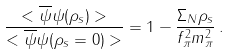Convert formula to latex. <formula><loc_0><loc_0><loc_500><loc_500>\frac { < \overline { \psi } \psi ( \rho _ { s } ) > } { < \overline { \psi } \psi ( \rho _ { s } = 0 ) > } = 1 - \frac { \Sigma _ { N } \rho _ { s } } { f _ { \pi } ^ { 2 } m _ { \pi } ^ { 2 } } \, .</formula> 